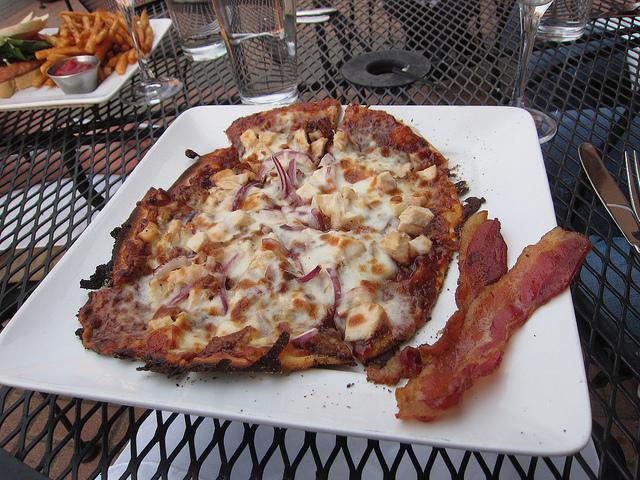How many pieces of bacon are next to the pizza?
Give a very brief answer. 2. How many wine glasses are there?
Give a very brief answer. 2. How many cups can you see?
Give a very brief answer. 2. 